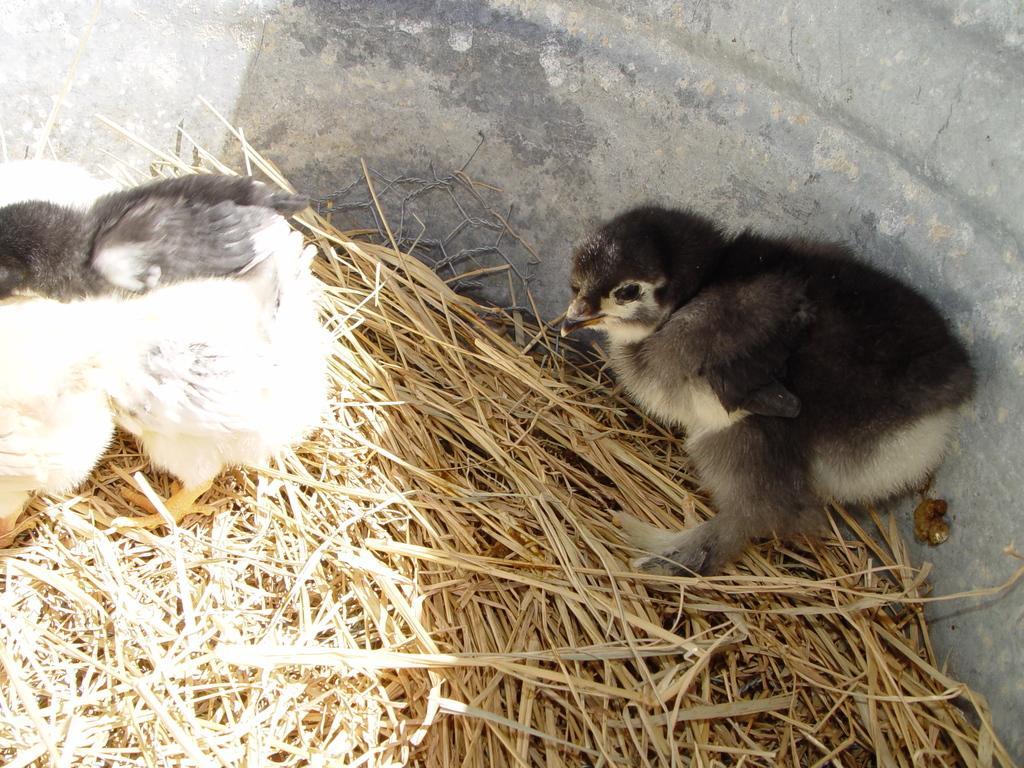How would you summarize this image in a sentence or two? This image consists of two birds. At the bottom, there is dry grass. It looks like they are kept in a pot. 